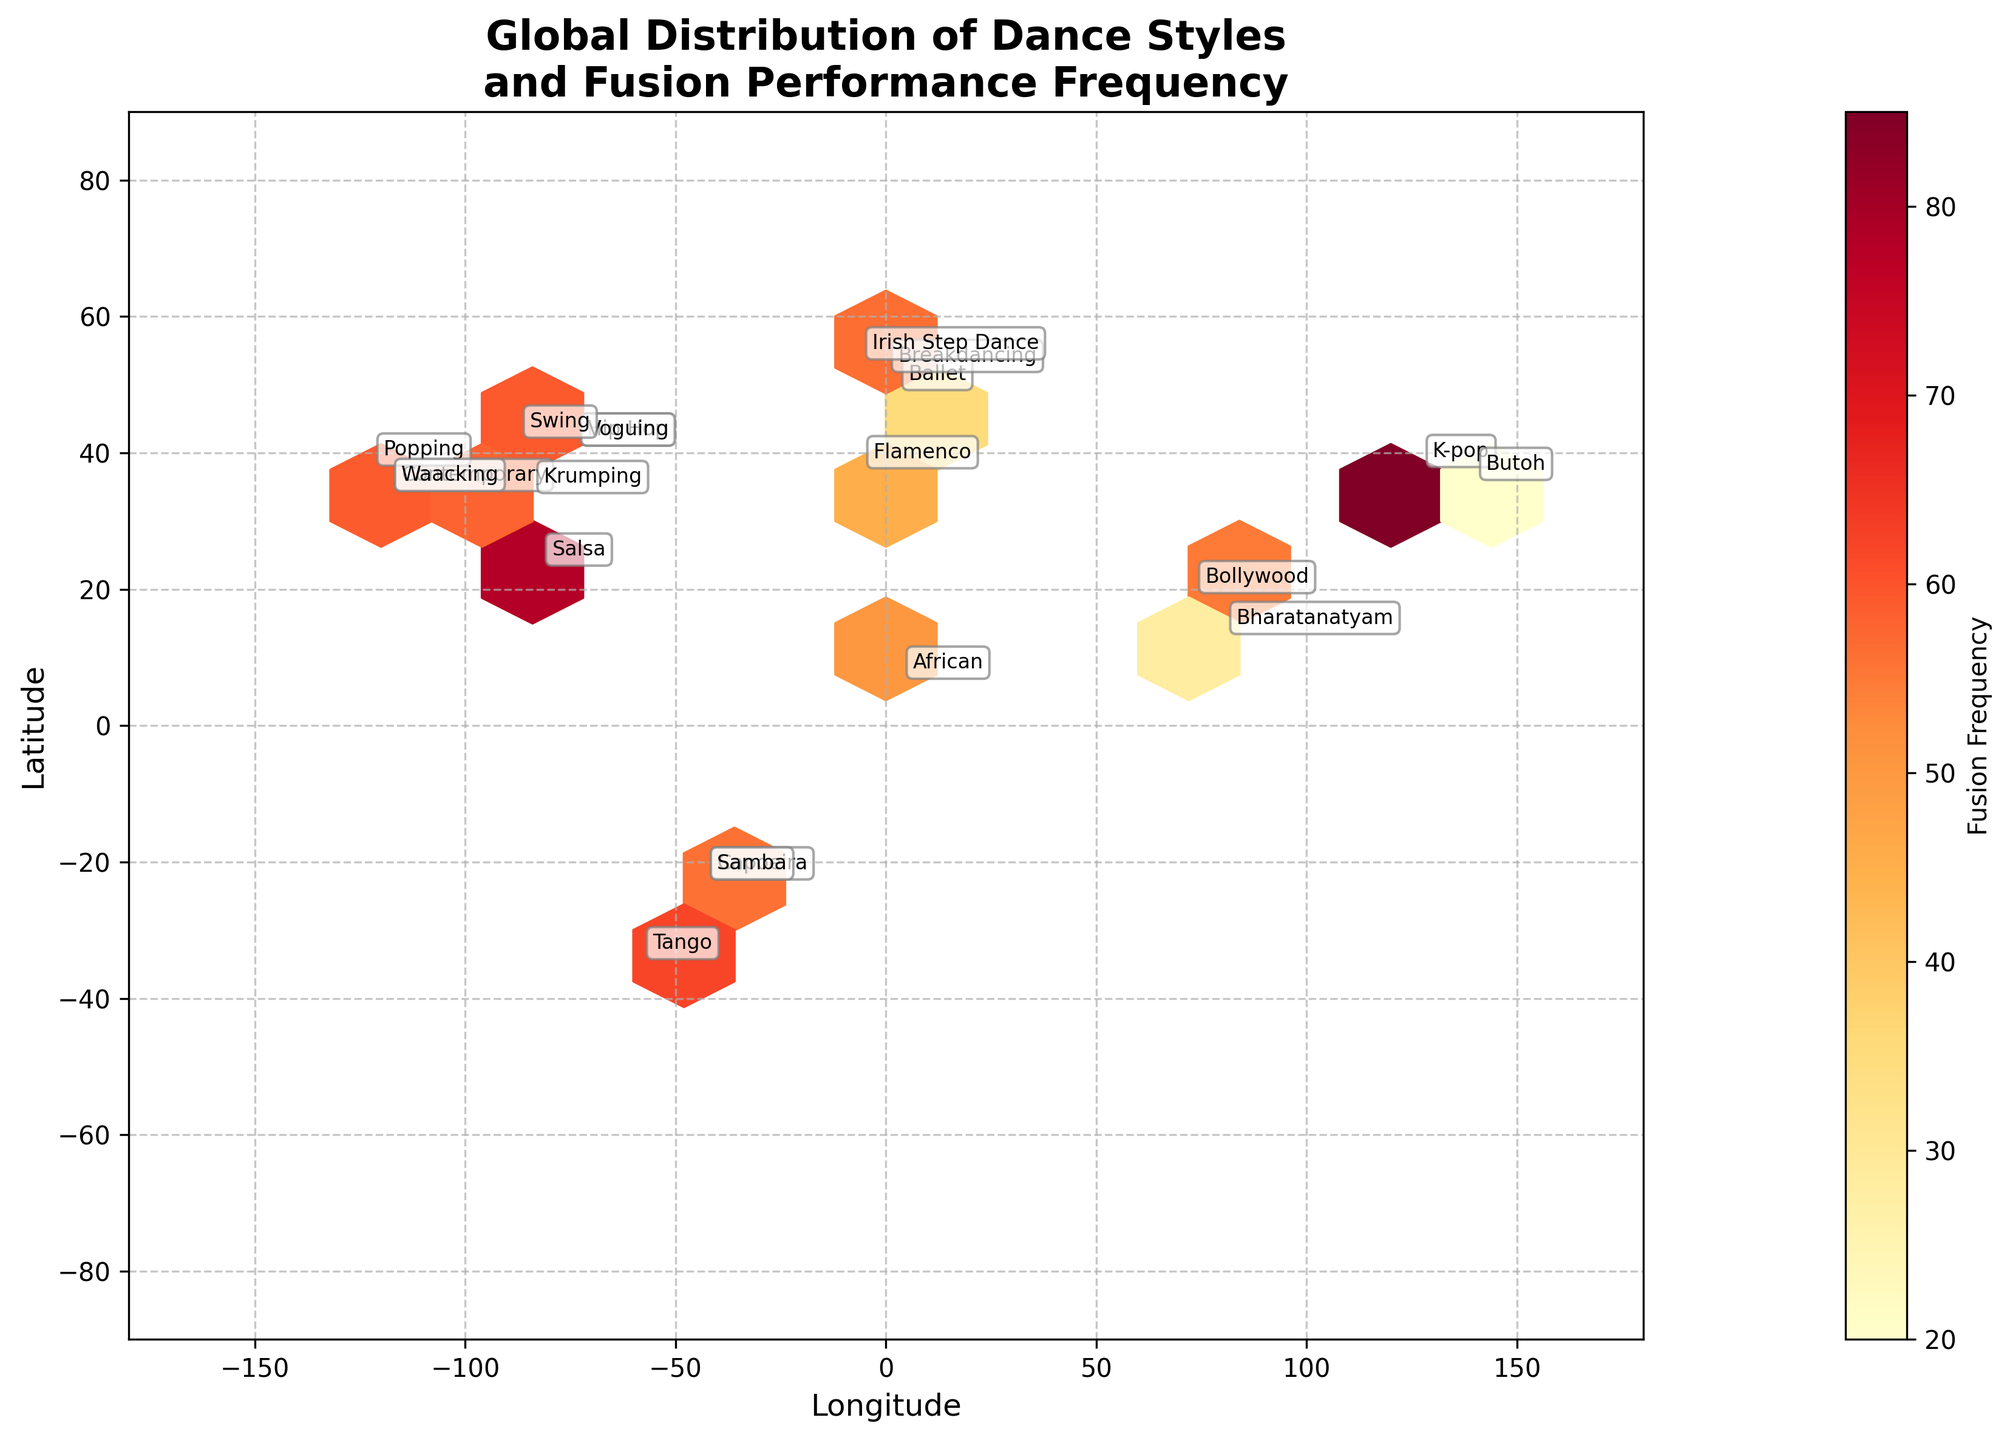What is the title of the plot? The title is usually located at the top of the plot. In this case, it reads "Global Distribution of Dance Styles and Fusion Performance Frequency".
Answer: Global Distribution of Dance Styles and Fusion Performance Frequency How many distinct dance styles are labeled on the plot? By counting each labeled dance style on the plot, we can see there are 18 unique dance styles.
Answer: 18 Which dance style has the highest fusion frequency according to the color intensity? By observing the hexagons' color representation of fusion frequency, we can see that Hip Hop has the highest fusion frequency at 92.
Answer: Hip Hop Which dance styles are mapped close to the latitude of about 34.0522 and longitude of about -118.2437? The plot annotations near the coordinates 34.0522 (latitude) and -118.2437 (longitude) show Contemporary and Waacking.
Answer: Contemporary and Waacking Which region (continent) appears to have the most diverse dance styles? By analyzing the geographical distribution and variety of labeled dance styles, Europe and North America seem to be the most diverse with multiple dance styles like Ballet, Flamenco, Breakdancing, and Hip Hop.
Answer: Europe and North America What is the fusion frequency range shown by the color bar? The color bar on the side of the plot indicates the range, which spans from 20 to 92.
Answer: 20-92 Which two dance styles located in Brazil show different fusion frequencies and what are these frequencies? By looking at the plot, Samba and Capoeira are both mapped around Brazil. Samba's fusion frequency is 72, while Capoeira's is 40.
Answer: Samba: 72, Capoeira: 40 Between Tango and Salsa, which has a higher fusion frequency and by how much? Tango has a frequency of 62 and Salsa has 78. The difference is 78 - 62 = 16.
Answer: Salsa by 16 How are the dance styles distributed in terms of geographic spread (latitude and longitude)? Observing the plot, dance styles are distributed across various latitudes and longitudes, implying a global spread. For instance, Bharatanatyam in India, Ballet in France, and Hip Hop in the USA show widespread geographic distribution.
Answer: Global Which dance style has the lower fusion frequency, Butoh or Krumping, and what are their respective frequencies? The annotations for Butoh and Krumping show fusion frequencies of 20 and 58, respectively. Therefore, Butoh has the lower fusion frequency.
Answer: Butoh: 20, Krumping: 58 